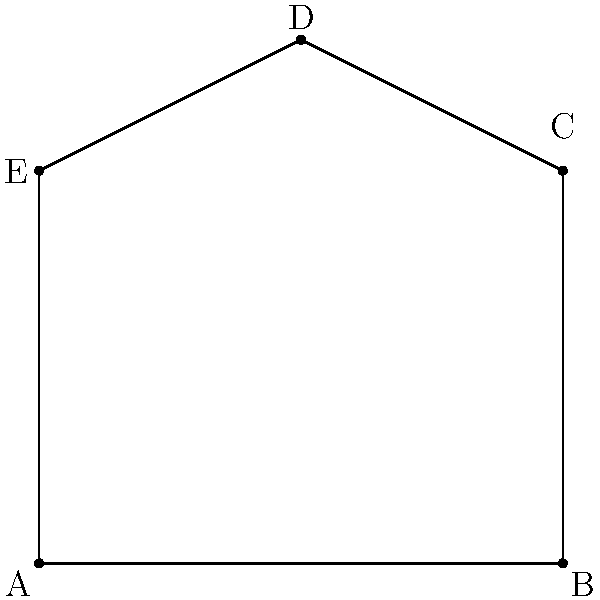In an image processing task, you've identified five feature points that form a polygon. The coordinates of these points are A(0,0), B(4,0), C(4,3), D(2,4), and E(0,3). Calculate the area of the polygon formed by these feature points. To calculate the area of this irregular polygon, we can use the Shoelace formula (also known as the surveyor's formula). The steps are as follows:

1) The Shoelace formula for a polygon with vertices $(x_1, y_1), (x_2, y_2), ..., (x_n, y_n)$ is:

   Area = $\frac{1}{2}|(x_1y_2 + x_2y_3 + ... + x_ny_1) - (y_1x_2 + y_2x_3 + ... + y_nx_1)|$

2) Let's arrange our points in order: A(0,0), B(4,0), C(4,3), D(2,4), E(0,3)

3) Now, let's apply the formula:

   Area = $\frac{1}{2}|[(0 \cdot 0 + 4 \cdot 3 + 4 \cdot 4 + 2 \cdot 3 + 0 \cdot 0) - (0 \cdot 4 + 0 \cdot 4 + 3 \cdot 2 + 4 \cdot 0 + 3 \cdot 0)]|$

4) Simplify:
   Area = $\frac{1}{2}|(0 + 12 + 16 + 6 + 0) - (0 + 0 + 6 + 0 + 0)|$
   
5) Calculate:
   Area = $\frac{1}{2}|34 - 6|$ = $\frac{1}{2} \cdot 28$ = 14

Therefore, the area of the polygon is 14 square units.
Answer: 14 square units 